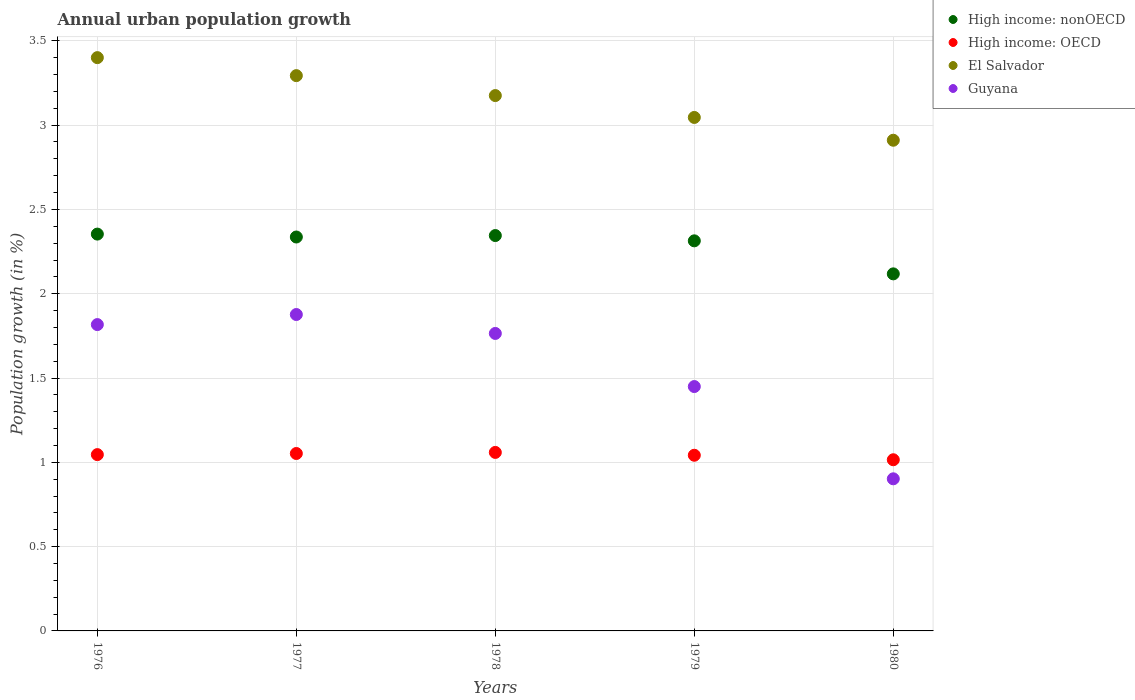How many different coloured dotlines are there?
Provide a succinct answer. 4. Is the number of dotlines equal to the number of legend labels?
Provide a succinct answer. Yes. What is the percentage of urban population growth in Guyana in 1977?
Offer a very short reply. 1.88. Across all years, what is the maximum percentage of urban population growth in El Salvador?
Provide a short and direct response. 3.4. Across all years, what is the minimum percentage of urban population growth in High income: OECD?
Offer a terse response. 1.02. In which year was the percentage of urban population growth in El Salvador maximum?
Make the answer very short. 1976. In which year was the percentage of urban population growth in High income: OECD minimum?
Keep it short and to the point. 1980. What is the total percentage of urban population growth in Guyana in the graph?
Your answer should be very brief. 7.81. What is the difference between the percentage of urban population growth in High income: OECD in 1977 and that in 1978?
Make the answer very short. -0.01. What is the difference between the percentage of urban population growth in High income: OECD in 1980 and the percentage of urban population growth in Guyana in 1977?
Your response must be concise. -0.86. What is the average percentage of urban population growth in High income: OECD per year?
Keep it short and to the point. 1.04. In the year 1977, what is the difference between the percentage of urban population growth in Guyana and percentage of urban population growth in High income: nonOECD?
Provide a short and direct response. -0.46. What is the ratio of the percentage of urban population growth in High income: OECD in 1977 to that in 1979?
Provide a short and direct response. 1.01. Is the percentage of urban population growth in High income: nonOECD in 1977 less than that in 1978?
Ensure brevity in your answer.  Yes. Is the difference between the percentage of urban population growth in Guyana in 1976 and 1977 greater than the difference between the percentage of urban population growth in High income: nonOECD in 1976 and 1977?
Offer a terse response. No. What is the difference between the highest and the second highest percentage of urban population growth in High income: nonOECD?
Give a very brief answer. 0.01. What is the difference between the highest and the lowest percentage of urban population growth in High income: nonOECD?
Your answer should be compact. 0.24. Is the sum of the percentage of urban population growth in El Salvador in 1977 and 1980 greater than the maximum percentage of urban population growth in High income: nonOECD across all years?
Ensure brevity in your answer.  Yes. Is it the case that in every year, the sum of the percentage of urban population growth in El Salvador and percentage of urban population growth in High income: nonOECD  is greater than the percentage of urban population growth in High income: OECD?
Provide a succinct answer. Yes. Is the percentage of urban population growth in High income: OECD strictly less than the percentage of urban population growth in El Salvador over the years?
Your answer should be compact. Yes. What is the difference between two consecutive major ticks on the Y-axis?
Offer a terse response. 0.5. How many legend labels are there?
Make the answer very short. 4. What is the title of the graph?
Your response must be concise. Annual urban population growth. What is the label or title of the X-axis?
Ensure brevity in your answer.  Years. What is the label or title of the Y-axis?
Your answer should be very brief. Population growth (in %). What is the Population growth (in %) in High income: nonOECD in 1976?
Your answer should be compact. 2.35. What is the Population growth (in %) in High income: OECD in 1976?
Provide a short and direct response. 1.05. What is the Population growth (in %) in El Salvador in 1976?
Your answer should be very brief. 3.4. What is the Population growth (in %) of Guyana in 1976?
Your response must be concise. 1.82. What is the Population growth (in %) in High income: nonOECD in 1977?
Your response must be concise. 2.34. What is the Population growth (in %) of High income: OECD in 1977?
Your response must be concise. 1.05. What is the Population growth (in %) of El Salvador in 1977?
Your answer should be very brief. 3.29. What is the Population growth (in %) in Guyana in 1977?
Provide a succinct answer. 1.88. What is the Population growth (in %) of High income: nonOECD in 1978?
Provide a succinct answer. 2.35. What is the Population growth (in %) in High income: OECD in 1978?
Your answer should be compact. 1.06. What is the Population growth (in %) in El Salvador in 1978?
Give a very brief answer. 3.18. What is the Population growth (in %) in Guyana in 1978?
Your answer should be compact. 1.76. What is the Population growth (in %) of High income: nonOECD in 1979?
Give a very brief answer. 2.31. What is the Population growth (in %) of High income: OECD in 1979?
Make the answer very short. 1.04. What is the Population growth (in %) in El Salvador in 1979?
Your answer should be compact. 3.05. What is the Population growth (in %) in Guyana in 1979?
Your answer should be very brief. 1.45. What is the Population growth (in %) of High income: nonOECD in 1980?
Offer a very short reply. 2.12. What is the Population growth (in %) in High income: OECD in 1980?
Your answer should be compact. 1.02. What is the Population growth (in %) of El Salvador in 1980?
Make the answer very short. 2.91. What is the Population growth (in %) in Guyana in 1980?
Your response must be concise. 0.9. Across all years, what is the maximum Population growth (in %) in High income: nonOECD?
Your response must be concise. 2.35. Across all years, what is the maximum Population growth (in %) in High income: OECD?
Make the answer very short. 1.06. Across all years, what is the maximum Population growth (in %) in El Salvador?
Provide a short and direct response. 3.4. Across all years, what is the maximum Population growth (in %) of Guyana?
Offer a very short reply. 1.88. Across all years, what is the minimum Population growth (in %) of High income: nonOECD?
Provide a short and direct response. 2.12. Across all years, what is the minimum Population growth (in %) of High income: OECD?
Offer a very short reply. 1.02. Across all years, what is the minimum Population growth (in %) of El Salvador?
Keep it short and to the point. 2.91. Across all years, what is the minimum Population growth (in %) of Guyana?
Your answer should be very brief. 0.9. What is the total Population growth (in %) in High income: nonOECD in the graph?
Keep it short and to the point. 11.47. What is the total Population growth (in %) in High income: OECD in the graph?
Provide a succinct answer. 5.21. What is the total Population growth (in %) of El Salvador in the graph?
Provide a short and direct response. 15.83. What is the total Population growth (in %) of Guyana in the graph?
Provide a short and direct response. 7.81. What is the difference between the Population growth (in %) in High income: nonOECD in 1976 and that in 1977?
Offer a terse response. 0.02. What is the difference between the Population growth (in %) in High income: OECD in 1976 and that in 1977?
Make the answer very short. -0.01. What is the difference between the Population growth (in %) of El Salvador in 1976 and that in 1977?
Provide a succinct answer. 0.11. What is the difference between the Population growth (in %) in Guyana in 1976 and that in 1977?
Keep it short and to the point. -0.06. What is the difference between the Population growth (in %) of High income: nonOECD in 1976 and that in 1978?
Your answer should be compact. 0.01. What is the difference between the Population growth (in %) in High income: OECD in 1976 and that in 1978?
Ensure brevity in your answer.  -0.01. What is the difference between the Population growth (in %) in El Salvador in 1976 and that in 1978?
Make the answer very short. 0.23. What is the difference between the Population growth (in %) of Guyana in 1976 and that in 1978?
Ensure brevity in your answer.  0.05. What is the difference between the Population growth (in %) of High income: nonOECD in 1976 and that in 1979?
Offer a terse response. 0.04. What is the difference between the Population growth (in %) of High income: OECD in 1976 and that in 1979?
Provide a succinct answer. 0. What is the difference between the Population growth (in %) in El Salvador in 1976 and that in 1979?
Your response must be concise. 0.35. What is the difference between the Population growth (in %) in Guyana in 1976 and that in 1979?
Your response must be concise. 0.37. What is the difference between the Population growth (in %) of High income: nonOECD in 1976 and that in 1980?
Provide a short and direct response. 0.24. What is the difference between the Population growth (in %) in High income: OECD in 1976 and that in 1980?
Offer a very short reply. 0.03. What is the difference between the Population growth (in %) in El Salvador in 1976 and that in 1980?
Your answer should be compact. 0.49. What is the difference between the Population growth (in %) of Guyana in 1976 and that in 1980?
Provide a succinct answer. 0.91. What is the difference between the Population growth (in %) in High income: nonOECD in 1977 and that in 1978?
Offer a terse response. -0.01. What is the difference between the Population growth (in %) of High income: OECD in 1977 and that in 1978?
Offer a very short reply. -0.01. What is the difference between the Population growth (in %) of El Salvador in 1977 and that in 1978?
Your answer should be compact. 0.12. What is the difference between the Population growth (in %) of Guyana in 1977 and that in 1978?
Your response must be concise. 0.11. What is the difference between the Population growth (in %) in High income: nonOECD in 1977 and that in 1979?
Your answer should be very brief. 0.02. What is the difference between the Population growth (in %) in High income: OECD in 1977 and that in 1979?
Keep it short and to the point. 0.01. What is the difference between the Population growth (in %) in El Salvador in 1977 and that in 1979?
Give a very brief answer. 0.25. What is the difference between the Population growth (in %) in Guyana in 1977 and that in 1979?
Make the answer very short. 0.43. What is the difference between the Population growth (in %) in High income: nonOECD in 1977 and that in 1980?
Give a very brief answer. 0.22. What is the difference between the Population growth (in %) in High income: OECD in 1977 and that in 1980?
Ensure brevity in your answer.  0.04. What is the difference between the Population growth (in %) in El Salvador in 1977 and that in 1980?
Give a very brief answer. 0.38. What is the difference between the Population growth (in %) in Guyana in 1977 and that in 1980?
Keep it short and to the point. 0.97. What is the difference between the Population growth (in %) in High income: nonOECD in 1978 and that in 1979?
Provide a succinct answer. 0.03. What is the difference between the Population growth (in %) of High income: OECD in 1978 and that in 1979?
Keep it short and to the point. 0.02. What is the difference between the Population growth (in %) of El Salvador in 1978 and that in 1979?
Keep it short and to the point. 0.13. What is the difference between the Population growth (in %) of Guyana in 1978 and that in 1979?
Make the answer very short. 0.32. What is the difference between the Population growth (in %) of High income: nonOECD in 1978 and that in 1980?
Ensure brevity in your answer.  0.23. What is the difference between the Population growth (in %) of High income: OECD in 1978 and that in 1980?
Your answer should be very brief. 0.04. What is the difference between the Population growth (in %) in El Salvador in 1978 and that in 1980?
Make the answer very short. 0.27. What is the difference between the Population growth (in %) of Guyana in 1978 and that in 1980?
Make the answer very short. 0.86. What is the difference between the Population growth (in %) of High income: nonOECD in 1979 and that in 1980?
Provide a short and direct response. 0.2. What is the difference between the Population growth (in %) in High income: OECD in 1979 and that in 1980?
Give a very brief answer. 0.03. What is the difference between the Population growth (in %) in El Salvador in 1979 and that in 1980?
Provide a short and direct response. 0.14. What is the difference between the Population growth (in %) of Guyana in 1979 and that in 1980?
Keep it short and to the point. 0.55. What is the difference between the Population growth (in %) of High income: nonOECD in 1976 and the Population growth (in %) of High income: OECD in 1977?
Make the answer very short. 1.3. What is the difference between the Population growth (in %) in High income: nonOECD in 1976 and the Population growth (in %) in El Salvador in 1977?
Your response must be concise. -0.94. What is the difference between the Population growth (in %) of High income: nonOECD in 1976 and the Population growth (in %) of Guyana in 1977?
Your response must be concise. 0.48. What is the difference between the Population growth (in %) in High income: OECD in 1976 and the Population growth (in %) in El Salvador in 1977?
Your answer should be very brief. -2.25. What is the difference between the Population growth (in %) of High income: OECD in 1976 and the Population growth (in %) of Guyana in 1977?
Keep it short and to the point. -0.83. What is the difference between the Population growth (in %) of El Salvador in 1976 and the Population growth (in %) of Guyana in 1977?
Provide a succinct answer. 1.52. What is the difference between the Population growth (in %) in High income: nonOECD in 1976 and the Population growth (in %) in High income: OECD in 1978?
Your answer should be compact. 1.29. What is the difference between the Population growth (in %) of High income: nonOECD in 1976 and the Population growth (in %) of El Salvador in 1978?
Your response must be concise. -0.82. What is the difference between the Population growth (in %) of High income: nonOECD in 1976 and the Population growth (in %) of Guyana in 1978?
Keep it short and to the point. 0.59. What is the difference between the Population growth (in %) in High income: OECD in 1976 and the Population growth (in %) in El Salvador in 1978?
Make the answer very short. -2.13. What is the difference between the Population growth (in %) of High income: OECD in 1976 and the Population growth (in %) of Guyana in 1978?
Keep it short and to the point. -0.72. What is the difference between the Population growth (in %) of El Salvador in 1976 and the Population growth (in %) of Guyana in 1978?
Provide a short and direct response. 1.64. What is the difference between the Population growth (in %) of High income: nonOECD in 1976 and the Population growth (in %) of High income: OECD in 1979?
Provide a succinct answer. 1.31. What is the difference between the Population growth (in %) in High income: nonOECD in 1976 and the Population growth (in %) in El Salvador in 1979?
Your answer should be very brief. -0.69. What is the difference between the Population growth (in %) of High income: nonOECD in 1976 and the Population growth (in %) of Guyana in 1979?
Make the answer very short. 0.9. What is the difference between the Population growth (in %) in High income: OECD in 1976 and the Population growth (in %) in El Salvador in 1979?
Your answer should be compact. -2. What is the difference between the Population growth (in %) of High income: OECD in 1976 and the Population growth (in %) of Guyana in 1979?
Your answer should be compact. -0.4. What is the difference between the Population growth (in %) in El Salvador in 1976 and the Population growth (in %) in Guyana in 1979?
Provide a succinct answer. 1.95. What is the difference between the Population growth (in %) in High income: nonOECD in 1976 and the Population growth (in %) in High income: OECD in 1980?
Keep it short and to the point. 1.34. What is the difference between the Population growth (in %) of High income: nonOECD in 1976 and the Population growth (in %) of El Salvador in 1980?
Provide a short and direct response. -0.56. What is the difference between the Population growth (in %) of High income: nonOECD in 1976 and the Population growth (in %) of Guyana in 1980?
Make the answer very short. 1.45. What is the difference between the Population growth (in %) of High income: OECD in 1976 and the Population growth (in %) of El Salvador in 1980?
Make the answer very short. -1.86. What is the difference between the Population growth (in %) in High income: OECD in 1976 and the Population growth (in %) in Guyana in 1980?
Ensure brevity in your answer.  0.14. What is the difference between the Population growth (in %) of El Salvador in 1976 and the Population growth (in %) of Guyana in 1980?
Give a very brief answer. 2.5. What is the difference between the Population growth (in %) in High income: nonOECD in 1977 and the Population growth (in %) in High income: OECD in 1978?
Ensure brevity in your answer.  1.28. What is the difference between the Population growth (in %) in High income: nonOECD in 1977 and the Population growth (in %) in El Salvador in 1978?
Provide a short and direct response. -0.84. What is the difference between the Population growth (in %) in High income: nonOECD in 1977 and the Population growth (in %) in Guyana in 1978?
Give a very brief answer. 0.57. What is the difference between the Population growth (in %) of High income: OECD in 1977 and the Population growth (in %) of El Salvador in 1978?
Provide a short and direct response. -2.12. What is the difference between the Population growth (in %) in High income: OECD in 1977 and the Population growth (in %) in Guyana in 1978?
Make the answer very short. -0.71. What is the difference between the Population growth (in %) in El Salvador in 1977 and the Population growth (in %) in Guyana in 1978?
Provide a succinct answer. 1.53. What is the difference between the Population growth (in %) in High income: nonOECD in 1977 and the Population growth (in %) in High income: OECD in 1979?
Give a very brief answer. 1.29. What is the difference between the Population growth (in %) of High income: nonOECD in 1977 and the Population growth (in %) of El Salvador in 1979?
Your answer should be compact. -0.71. What is the difference between the Population growth (in %) in High income: nonOECD in 1977 and the Population growth (in %) in Guyana in 1979?
Your response must be concise. 0.89. What is the difference between the Population growth (in %) in High income: OECD in 1977 and the Population growth (in %) in El Salvador in 1979?
Keep it short and to the point. -1.99. What is the difference between the Population growth (in %) of High income: OECD in 1977 and the Population growth (in %) of Guyana in 1979?
Ensure brevity in your answer.  -0.4. What is the difference between the Population growth (in %) of El Salvador in 1977 and the Population growth (in %) of Guyana in 1979?
Give a very brief answer. 1.84. What is the difference between the Population growth (in %) in High income: nonOECD in 1977 and the Population growth (in %) in High income: OECD in 1980?
Provide a short and direct response. 1.32. What is the difference between the Population growth (in %) in High income: nonOECD in 1977 and the Population growth (in %) in El Salvador in 1980?
Your response must be concise. -0.57. What is the difference between the Population growth (in %) in High income: nonOECD in 1977 and the Population growth (in %) in Guyana in 1980?
Give a very brief answer. 1.43. What is the difference between the Population growth (in %) in High income: OECD in 1977 and the Population growth (in %) in El Salvador in 1980?
Your answer should be very brief. -1.86. What is the difference between the Population growth (in %) of High income: OECD in 1977 and the Population growth (in %) of Guyana in 1980?
Give a very brief answer. 0.15. What is the difference between the Population growth (in %) of El Salvador in 1977 and the Population growth (in %) of Guyana in 1980?
Your answer should be compact. 2.39. What is the difference between the Population growth (in %) of High income: nonOECD in 1978 and the Population growth (in %) of High income: OECD in 1979?
Offer a very short reply. 1.3. What is the difference between the Population growth (in %) in High income: nonOECD in 1978 and the Population growth (in %) in El Salvador in 1979?
Ensure brevity in your answer.  -0.7. What is the difference between the Population growth (in %) in High income: nonOECD in 1978 and the Population growth (in %) in Guyana in 1979?
Offer a very short reply. 0.9. What is the difference between the Population growth (in %) of High income: OECD in 1978 and the Population growth (in %) of El Salvador in 1979?
Provide a short and direct response. -1.99. What is the difference between the Population growth (in %) of High income: OECD in 1978 and the Population growth (in %) of Guyana in 1979?
Your answer should be very brief. -0.39. What is the difference between the Population growth (in %) of El Salvador in 1978 and the Population growth (in %) of Guyana in 1979?
Your response must be concise. 1.73. What is the difference between the Population growth (in %) of High income: nonOECD in 1978 and the Population growth (in %) of High income: OECD in 1980?
Your answer should be compact. 1.33. What is the difference between the Population growth (in %) of High income: nonOECD in 1978 and the Population growth (in %) of El Salvador in 1980?
Provide a short and direct response. -0.57. What is the difference between the Population growth (in %) of High income: nonOECD in 1978 and the Population growth (in %) of Guyana in 1980?
Give a very brief answer. 1.44. What is the difference between the Population growth (in %) of High income: OECD in 1978 and the Population growth (in %) of El Salvador in 1980?
Offer a very short reply. -1.85. What is the difference between the Population growth (in %) in High income: OECD in 1978 and the Population growth (in %) in Guyana in 1980?
Offer a very short reply. 0.16. What is the difference between the Population growth (in %) of El Salvador in 1978 and the Population growth (in %) of Guyana in 1980?
Make the answer very short. 2.27. What is the difference between the Population growth (in %) in High income: nonOECD in 1979 and the Population growth (in %) in High income: OECD in 1980?
Make the answer very short. 1.3. What is the difference between the Population growth (in %) of High income: nonOECD in 1979 and the Population growth (in %) of El Salvador in 1980?
Ensure brevity in your answer.  -0.6. What is the difference between the Population growth (in %) in High income: nonOECD in 1979 and the Population growth (in %) in Guyana in 1980?
Provide a short and direct response. 1.41. What is the difference between the Population growth (in %) of High income: OECD in 1979 and the Population growth (in %) of El Salvador in 1980?
Your response must be concise. -1.87. What is the difference between the Population growth (in %) of High income: OECD in 1979 and the Population growth (in %) of Guyana in 1980?
Give a very brief answer. 0.14. What is the difference between the Population growth (in %) of El Salvador in 1979 and the Population growth (in %) of Guyana in 1980?
Keep it short and to the point. 2.14. What is the average Population growth (in %) of High income: nonOECD per year?
Provide a short and direct response. 2.29. What is the average Population growth (in %) of High income: OECD per year?
Offer a very short reply. 1.04. What is the average Population growth (in %) of El Salvador per year?
Provide a succinct answer. 3.17. What is the average Population growth (in %) of Guyana per year?
Keep it short and to the point. 1.56. In the year 1976, what is the difference between the Population growth (in %) of High income: nonOECD and Population growth (in %) of High income: OECD?
Ensure brevity in your answer.  1.31. In the year 1976, what is the difference between the Population growth (in %) of High income: nonOECD and Population growth (in %) of El Salvador?
Your answer should be very brief. -1.05. In the year 1976, what is the difference between the Population growth (in %) of High income: nonOECD and Population growth (in %) of Guyana?
Provide a short and direct response. 0.54. In the year 1976, what is the difference between the Population growth (in %) in High income: OECD and Population growth (in %) in El Salvador?
Ensure brevity in your answer.  -2.35. In the year 1976, what is the difference between the Population growth (in %) of High income: OECD and Population growth (in %) of Guyana?
Your answer should be very brief. -0.77. In the year 1976, what is the difference between the Population growth (in %) in El Salvador and Population growth (in %) in Guyana?
Offer a very short reply. 1.58. In the year 1977, what is the difference between the Population growth (in %) of High income: nonOECD and Population growth (in %) of High income: OECD?
Offer a very short reply. 1.28. In the year 1977, what is the difference between the Population growth (in %) in High income: nonOECD and Population growth (in %) in El Salvador?
Your answer should be compact. -0.96. In the year 1977, what is the difference between the Population growth (in %) of High income: nonOECD and Population growth (in %) of Guyana?
Make the answer very short. 0.46. In the year 1977, what is the difference between the Population growth (in %) in High income: OECD and Population growth (in %) in El Salvador?
Give a very brief answer. -2.24. In the year 1977, what is the difference between the Population growth (in %) of High income: OECD and Population growth (in %) of Guyana?
Make the answer very short. -0.82. In the year 1977, what is the difference between the Population growth (in %) of El Salvador and Population growth (in %) of Guyana?
Your response must be concise. 1.42. In the year 1978, what is the difference between the Population growth (in %) of High income: nonOECD and Population growth (in %) of High income: OECD?
Give a very brief answer. 1.29. In the year 1978, what is the difference between the Population growth (in %) in High income: nonOECD and Population growth (in %) in El Salvador?
Make the answer very short. -0.83. In the year 1978, what is the difference between the Population growth (in %) of High income: nonOECD and Population growth (in %) of Guyana?
Keep it short and to the point. 0.58. In the year 1978, what is the difference between the Population growth (in %) in High income: OECD and Population growth (in %) in El Salvador?
Your answer should be very brief. -2.12. In the year 1978, what is the difference between the Population growth (in %) of High income: OECD and Population growth (in %) of Guyana?
Give a very brief answer. -0.71. In the year 1978, what is the difference between the Population growth (in %) in El Salvador and Population growth (in %) in Guyana?
Your response must be concise. 1.41. In the year 1979, what is the difference between the Population growth (in %) of High income: nonOECD and Population growth (in %) of High income: OECD?
Your answer should be very brief. 1.27. In the year 1979, what is the difference between the Population growth (in %) of High income: nonOECD and Population growth (in %) of El Salvador?
Your answer should be compact. -0.73. In the year 1979, what is the difference between the Population growth (in %) of High income: nonOECD and Population growth (in %) of Guyana?
Make the answer very short. 0.86. In the year 1979, what is the difference between the Population growth (in %) in High income: OECD and Population growth (in %) in El Salvador?
Make the answer very short. -2. In the year 1979, what is the difference between the Population growth (in %) in High income: OECD and Population growth (in %) in Guyana?
Make the answer very short. -0.41. In the year 1979, what is the difference between the Population growth (in %) of El Salvador and Population growth (in %) of Guyana?
Provide a short and direct response. 1.6. In the year 1980, what is the difference between the Population growth (in %) of High income: nonOECD and Population growth (in %) of High income: OECD?
Make the answer very short. 1.1. In the year 1980, what is the difference between the Population growth (in %) of High income: nonOECD and Population growth (in %) of El Salvador?
Provide a short and direct response. -0.79. In the year 1980, what is the difference between the Population growth (in %) in High income: nonOECD and Population growth (in %) in Guyana?
Provide a succinct answer. 1.22. In the year 1980, what is the difference between the Population growth (in %) of High income: OECD and Population growth (in %) of El Salvador?
Ensure brevity in your answer.  -1.9. In the year 1980, what is the difference between the Population growth (in %) of High income: OECD and Population growth (in %) of Guyana?
Give a very brief answer. 0.11. In the year 1980, what is the difference between the Population growth (in %) in El Salvador and Population growth (in %) in Guyana?
Offer a terse response. 2.01. What is the ratio of the Population growth (in %) in High income: nonOECD in 1976 to that in 1977?
Your answer should be very brief. 1.01. What is the ratio of the Population growth (in %) of El Salvador in 1976 to that in 1977?
Offer a terse response. 1.03. What is the ratio of the Population growth (in %) in Guyana in 1976 to that in 1977?
Your answer should be compact. 0.97. What is the ratio of the Population growth (in %) in High income: OECD in 1976 to that in 1978?
Your answer should be very brief. 0.99. What is the ratio of the Population growth (in %) in El Salvador in 1976 to that in 1978?
Keep it short and to the point. 1.07. What is the ratio of the Population growth (in %) in Guyana in 1976 to that in 1978?
Provide a succinct answer. 1.03. What is the ratio of the Population growth (in %) of High income: nonOECD in 1976 to that in 1979?
Ensure brevity in your answer.  1.02. What is the ratio of the Population growth (in %) in El Salvador in 1976 to that in 1979?
Your answer should be very brief. 1.12. What is the ratio of the Population growth (in %) of Guyana in 1976 to that in 1979?
Offer a very short reply. 1.25. What is the ratio of the Population growth (in %) in High income: nonOECD in 1976 to that in 1980?
Provide a succinct answer. 1.11. What is the ratio of the Population growth (in %) in High income: OECD in 1976 to that in 1980?
Ensure brevity in your answer.  1.03. What is the ratio of the Population growth (in %) in El Salvador in 1976 to that in 1980?
Provide a succinct answer. 1.17. What is the ratio of the Population growth (in %) in Guyana in 1976 to that in 1980?
Give a very brief answer. 2.01. What is the ratio of the Population growth (in %) of High income: nonOECD in 1977 to that in 1978?
Your response must be concise. 1. What is the ratio of the Population growth (in %) of High income: OECD in 1977 to that in 1978?
Keep it short and to the point. 0.99. What is the ratio of the Population growth (in %) of El Salvador in 1977 to that in 1978?
Keep it short and to the point. 1.04. What is the ratio of the Population growth (in %) of Guyana in 1977 to that in 1978?
Provide a succinct answer. 1.06. What is the ratio of the Population growth (in %) in High income: nonOECD in 1977 to that in 1979?
Provide a short and direct response. 1.01. What is the ratio of the Population growth (in %) in El Salvador in 1977 to that in 1979?
Provide a succinct answer. 1.08. What is the ratio of the Population growth (in %) in Guyana in 1977 to that in 1979?
Keep it short and to the point. 1.29. What is the ratio of the Population growth (in %) in High income: nonOECD in 1977 to that in 1980?
Offer a very short reply. 1.1. What is the ratio of the Population growth (in %) in High income: OECD in 1977 to that in 1980?
Your response must be concise. 1.04. What is the ratio of the Population growth (in %) of El Salvador in 1977 to that in 1980?
Offer a very short reply. 1.13. What is the ratio of the Population growth (in %) in Guyana in 1977 to that in 1980?
Give a very brief answer. 2.08. What is the ratio of the Population growth (in %) of High income: nonOECD in 1978 to that in 1979?
Make the answer very short. 1.01. What is the ratio of the Population growth (in %) in High income: OECD in 1978 to that in 1979?
Your answer should be compact. 1.02. What is the ratio of the Population growth (in %) in El Salvador in 1978 to that in 1979?
Provide a succinct answer. 1.04. What is the ratio of the Population growth (in %) in Guyana in 1978 to that in 1979?
Keep it short and to the point. 1.22. What is the ratio of the Population growth (in %) in High income: nonOECD in 1978 to that in 1980?
Provide a short and direct response. 1.11. What is the ratio of the Population growth (in %) of High income: OECD in 1978 to that in 1980?
Provide a succinct answer. 1.04. What is the ratio of the Population growth (in %) of El Salvador in 1978 to that in 1980?
Offer a very short reply. 1.09. What is the ratio of the Population growth (in %) in Guyana in 1978 to that in 1980?
Keep it short and to the point. 1.96. What is the ratio of the Population growth (in %) in High income: nonOECD in 1979 to that in 1980?
Provide a succinct answer. 1.09. What is the ratio of the Population growth (in %) in High income: OECD in 1979 to that in 1980?
Keep it short and to the point. 1.03. What is the ratio of the Population growth (in %) in El Salvador in 1979 to that in 1980?
Provide a short and direct response. 1.05. What is the ratio of the Population growth (in %) in Guyana in 1979 to that in 1980?
Your answer should be very brief. 1.61. What is the difference between the highest and the second highest Population growth (in %) in High income: nonOECD?
Offer a very short reply. 0.01. What is the difference between the highest and the second highest Population growth (in %) of High income: OECD?
Your response must be concise. 0.01. What is the difference between the highest and the second highest Population growth (in %) in El Salvador?
Offer a terse response. 0.11. What is the difference between the highest and the second highest Population growth (in %) in Guyana?
Give a very brief answer. 0.06. What is the difference between the highest and the lowest Population growth (in %) of High income: nonOECD?
Offer a terse response. 0.24. What is the difference between the highest and the lowest Population growth (in %) in High income: OECD?
Provide a short and direct response. 0.04. What is the difference between the highest and the lowest Population growth (in %) of El Salvador?
Offer a terse response. 0.49. What is the difference between the highest and the lowest Population growth (in %) of Guyana?
Provide a short and direct response. 0.97. 